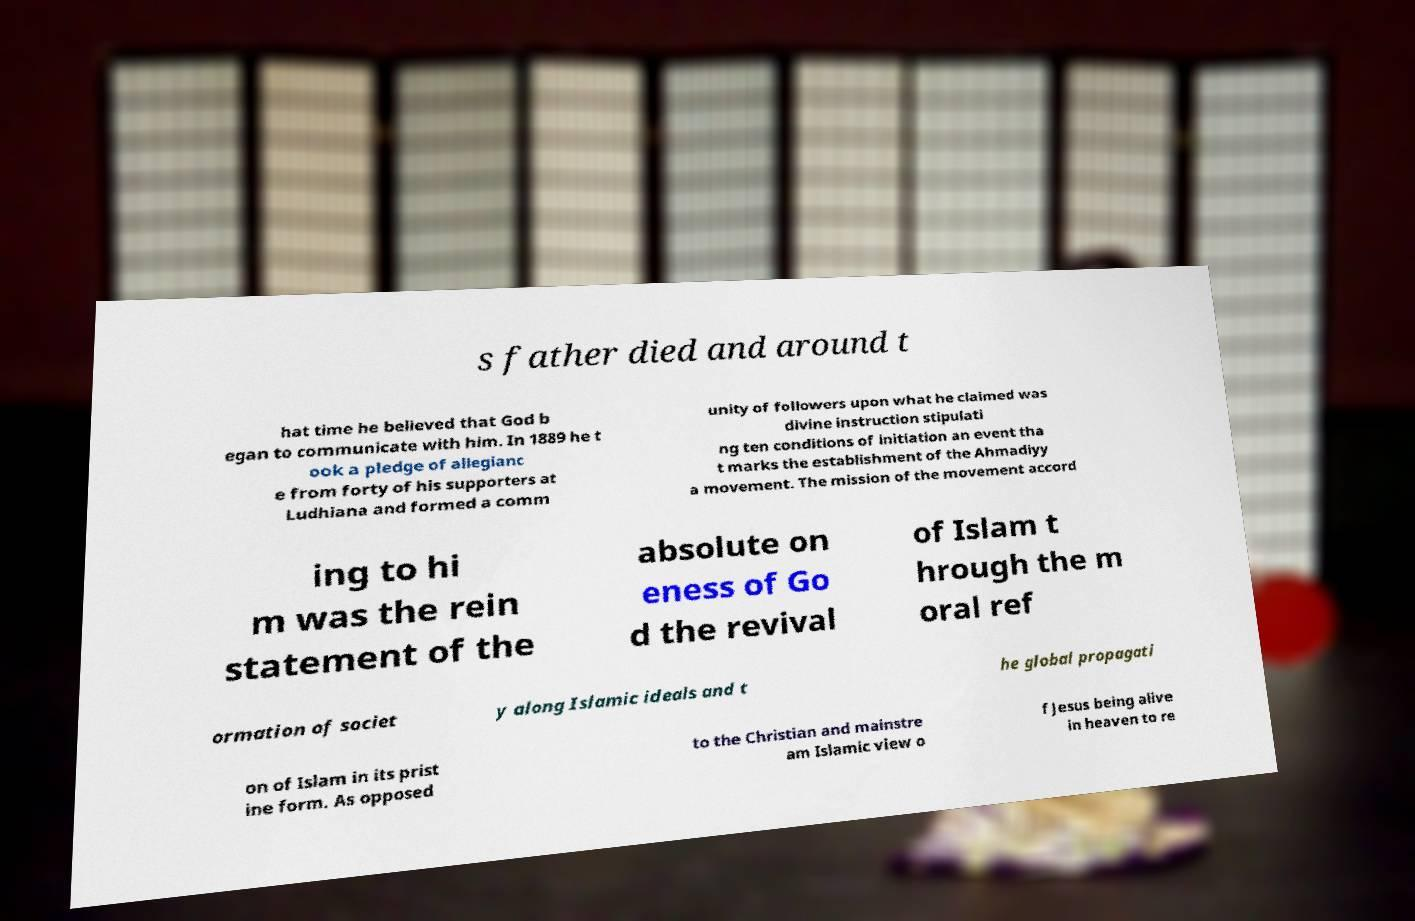Could you assist in decoding the text presented in this image and type it out clearly? s father died and around t hat time he believed that God b egan to communicate with him. In 1889 he t ook a pledge of allegianc e from forty of his supporters at Ludhiana and formed a comm unity of followers upon what he claimed was divine instruction stipulati ng ten conditions of initiation an event tha t marks the establishment of the Ahmadiyy a movement. The mission of the movement accord ing to hi m was the rein statement of the absolute on eness of Go d the revival of Islam t hrough the m oral ref ormation of societ y along Islamic ideals and t he global propagati on of Islam in its prist ine form. As opposed to the Christian and mainstre am Islamic view o f Jesus being alive in heaven to re 